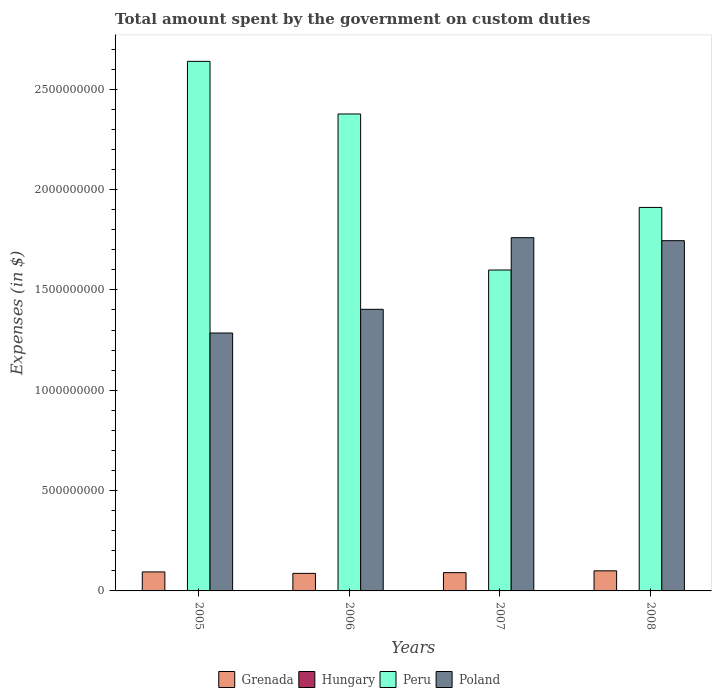How many different coloured bars are there?
Your response must be concise. 3. Are the number of bars per tick equal to the number of legend labels?
Your answer should be very brief. No. How many bars are there on the 2nd tick from the right?
Ensure brevity in your answer.  3. What is the label of the 3rd group of bars from the left?
Your response must be concise. 2007. What is the amount spent on custom duties by the government in Peru in 2006?
Give a very brief answer. 2.38e+09. Across all years, what is the maximum amount spent on custom duties by the government in Poland?
Make the answer very short. 1.76e+09. Across all years, what is the minimum amount spent on custom duties by the government in Hungary?
Offer a very short reply. 0. In which year was the amount spent on custom duties by the government in Poland maximum?
Your response must be concise. 2007. What is the difference between the amount spent on custom duties by the government in Peru in 2007 and that in 2008?
Your answer should be very brief. -3.12e+08. What is the difference between the amount spent on custom duties by the government in Poland in 2008 and the amount spent on custom duties by the government in Peru in 2006?
Offer a very short reply. -6.31e+08. What is the average amount spent on custom duties by the government in Peru per year?
Your answer should be compact. 2.13e+09. In the year 2005, what is the difference between the amount spent on custom duties by the government in Poland and amount spent on custom duties by the government in Grenada?
Your answer should be compact. 1.19e+09. In how many years, is the amount spent on custom duties by the government in Poland greater than 500000000 $?
Keep it short and to the point. 4. What is the ratio of the amount spent on custom duties by the government in Peru in 2005 to that in 2008?
Provide a succinct answer. 1.38. What is the difference between the highest and the second highest amount spent on custom duties by the government in Peru?
Offer a very short reply. 2.62e+08. What is the difference between the highest and the lowest amount spent on custom duties by the government in Peru?
Ensure brevity in your answer.  1.04e+09. In how many years, is the amount spent on custom duties by the government in Peru greater than the average amount spent on custom duties by the government in Peru taken over all years?
Your response must be concise. 2. Is it the case that in every year, the sum of the amount spent on custom duties by the government in Hungary and amount spent on custom duties by the government in Poland is greater than the sum of amount spent on custom duties by the government in Grenada and amount spent on custom duties by the government in Peru?
Keep it short and to the point. Yes. How many bars are there?
Make the answer very short. 12. Are all the bars in the graph horizontal?
Give a very brief answer. No. How many years are there in the graph?
Offer a very short reply. 4. What is the difference between two consecutive major ticks on the Y-axis?
Your answer should be very brief. 5.00e+08. Where does the legend appear in the graph?
Offer a very short reply. Bottom center. How are the legend labels stacked?
Your answer should be very brief. Horizontal. What is the title of the graph?
Offer a terse response. Total amount spent by the government on custom duties. What is the label or title of the X-axis?
Your answer should be very brief. Years. What is the label or title of the Y-axis?
Keep it short and to the point. Expenses (in $). What is the Expenses (in $) of Grenada in 2005?
Provide a short and direct response. 9.47e+07. What is the Expenses (in $) in Hungary in 2005?
Provide a short and direct response. 0. What is the Expenses (in $) of Peru in 2005?
Provide a succinct answer. 2.64e+09. What is the Expenses (in $) of Poland in 2005?
Provide a succinct answer. 1.28e+09. What is the Expenses (in $) of Grenada in 2006?
Ensure brevity in your answer.  8.74e+07. What is the Expenses (in $) in Peru in 2006?
Ensure brevity in your answer.  2.38e+09. What is the Expenses (in $) of Poland in 2006?
Provide a succinct answer. 1.40e+09. What is the Expenses (in $) in Grenada in 2007?
Make the answer very short. 9.11e+07. What is the Expenses (in $) in Peru in 2007?
Keep it short and to the point. 1.60e+09. What is the Expenses (in $) in Poland in 2007?
Your answer should be very brief. 1.76e+09. What is the Expenses (in $) in Grenada in 2008?
Offer a very short reply. 1.00e+08. What is the Expenses (in $) of Peru in 2008?
Your answer should be very brief. 1.91e+09. What is the Expenses (in $) of Poland in 2008?
Keep it short and to the point. 1.74e+09. Across all years, what is the maximum Expenses (in $) of Grenada?
Your answer should be compact. 1.00e+08. Across all years, what is the maximum Expenses (in $) of Peru?
Provide a short and direct response. 2.64e+09. Across all years, what is the maximum Expenses (in $) in Poland?
Your answer should be very brief. 1.76e+09. Across all years, what is the minimum Expenses (in $) of Grenada?
Provide a succinct answer. 8.74e+07. Across all years, what is the minimum Expenses (in $) of Peru?
Provide a succinct answer. 1.60e+09. Across all years, what is the minimum Expenses (in $) in Poland?
Provide a succinct answer. 1.28e+09. What is the total Expenses (in $) of Grenada in the graph?
Offer a terse response. 3.73e+08. What is the total Expenses (in $) in Peru in the graph?
Your answer should be compact. 8.52e+09. What is the total Expenses (in $) in Poland in the graph?
Your answer should be compact. 6.19e+09. What is the difference between the Expenses (in $) of Grenada in 2005 and that in 2006?
Your answer should be compact. 7.30e+06. What is the difference between the Expenses (in $) of Peru in 2005 and that in 2006?
Provide a succinct answer. 2.62e+08. What is the difference between the Expenses (in $) of Poland in 2005 and that in 2006?
Your answer should be very brief. -1.18e+08. What is the difference between the Expenses (in $) of Grenada in 2005 and that in 2007?
Give a very brief answer. 3.60e+06. What is the difference between the Expenses (in $) in Peru in 2005 and that in 2007?
Ensure brevity in your answer.  1.04e+09. What is the difference between the Expenses (in $) in Poland in 2005 and that in 2007?
Keep it short and to the point. -4.75e+08. What is the difference between the Expenses (in $) in Grenada in 2005 and that in 2008?
Give a very brief answer. -5.40e+06. What is the difference between the Expenses (in $) of Peru in 2005 and that in 2008?
Ensure brevity in your answer.  7.28e+08. What is the difference between the Expenses (in $) of Poland in 2005 and that in 2008?
Your answer should be compact. -4.60e+08. What is the difference between the Expenses (in $) in Grenada in 2006 and that in 2007?
Your response must be concise. -3.70e+06. What is the difference between the Expenses (in $) of Peru in 2006 and that in 2007?
Provide a succinct answer. 7.77e+08. What is the difference between the Expenses (in $) in Poland in 2006 and that in 2007?
Provide a succinct answer. -3.57e+08. What is the difference between the Expenses (in $) of Grenada in 2006 and that in 2008?
Your answer should be compact. -1.27e+07. What is the difference between the Expenses (in $) of Peru in 2006 and that in 2008?
Give a very brief answer. 4.66e+08. What is the difference between the Expenses (in $) in Poland in 2006 and that in 2008?
Provide a short and direct response. -3.42e+08. What is the difference between the Expenses (in $) in Grenada in 2007 and that in 2008?
Your answer should be compact. -9.00e+06. What is the difference between the Expenses (in $) in Peru in 2007 and that in 2008?
Provide a succinct answer. -3.12e+08. What is the difference between the Expenses (in $) in Poland in 2007 and that in 2008?
Give a very brief answer. 1.50e+07. What is the difference between the Expenses (in $) of Grenada in 2005 and the Expenses (in $) of Peru in 2006?
Keep it short and to the point. -2.28e+09. What is the difference between the Expenses (in $) of Grenada in 2005 and the Expenses (in $) of Poland in 2006?
Your response must be concise. -1.31e+09. What is the difference between the Expenses (in $) of Peru in 2005 and the Expenses (in $) of Poland in 2006?
Your answer should be compact. 1.24e+09. What is the difference between the Expenses (in $) in Grenada in 2005 and the Expenses (in $) in Peru in 2007?
Offer a terse response. -1.50e+09. What is the difference between the Expenses (in $) of Grenada in 2005 and the Expenses (in $) of Poland in 2007?
Your answer should be compact. -1.67e+09. What is the difference between the Expenses (in $) in Peru in 2005 and the Expenses (in $) in Poland in 2007?
Offer a terse response. 8.78e+08. What is the difference between the Expenses (in $) of Grenada in 2005 and the Expenses (in $) of Peru in 2008?
Keep it short and to the point. -1.82e+09. What is the difference between the Expenses (in $) of Grenada in 2005 and the Expenses (in $) of Poland in 2008?
Give a very brief answer. -1.65e+09. What is the difference between the Expenses (in $) in Peru in 2005 and the Expenses (in $) in Poland in 2008?
Make the answer very short. 8.94e+08. What is the difference between the Expenses (in $) of Grenada in 2006 and the Expenses (in $) of Peru in 2007?
Your response must be concise. -1.51e+09. What is the difference between the Expenses (in $) in Grenada in 2006 and the Expenses (in $) in Poland in 2007?
Ensure brevity in your answer.  -1.67e+09. What is the difference between the Expenses (in $) in Peru in 2006 and the Expenses (in $) in Poland in 2007?
Your answer should be very brief. 6.16e+08. What is the difference between the Expenses (in $) in Grenada in 2006 and the Expenses (in $) in Peru in 2008?
Offer a terse response. -1.82e+09. What is the difference between the Expenses (in $) in Grenada in 2006 and the Expenses (in $) in Poland in 2008?
Your answer should be very brief. -1.66e+09. What is the difference between the Expenses (in $) in Peru in 2006 and the Expenses (in $) in Poland in 2008?
Make the answer very short. 6.31e+08. What is the difference between the Expenses (in $) in Grenada in 2007 and the Expenses (in $) in Peru in 2008?
Give a very brief answer. -1.82e+09. What is the difference between the Expenses (in $) of Grenada in 2007 and the Expenses (in $) of Poland in 2008?
Ensure brevity in your answer.  -1.65e+09. What is the difference between the Expenses (in $) of Peru in 2007 and the Expenses (in $) of Poland in 2008?
Make the answer very short. -1.46e+08. What is the average Expenses (in $) in Grenada per year?
Your response must be concise. 9.33e+07. What is the average Expenses (in $) in Peru per year?
Provide a succinct answer. 2.13e+09. What is the average Expenses (in $) of Poland per year?
Keep it short and to the point. 1.55e+09. In the year 2005, what is the difference between the Expenses (in $) of Grenada and Expenses (in $) of Peru?
Your response must be concise. -2.54e+09. In the year 2005, what is the difference between the Expenses (in $) in Grenada and Expenses (in $) in Poland?
Provide a succinct answer. -1.19e+09. In the year 2005, what is the difference between the Expenses (in $) of Peru and Expenses (in $) of Poland?
Provide a short and direct response. 1.35e+09. In the year 2006, what is the difference between the Expenses (in $) in Grenada and Expenses (in $) in Peru?
Give a very brief answer. -2.29e+09. In the year 2006, what is the difference between the Expenses (in $) in Grenada and Expenses (in $) in Poland?
Provide a succinct answer. -1.32e+09. In the year 2006, what is the difference between the Expenses (in $) in Peru and Expenses (in $) in Poland?
Make the answer very short. 9.73e+08. In the year 2007, what is the difference between the Expenses (in $) of Grenada and Expenses (in $) of Peru?
Your answer should be very brief. -1.51e+09. In the year 2007, what is the difference between the Expenses (in $) in Grenada and Expenses (in $) in Poland?
Offer a very short reply. -1.67e+09. In the year 2007, what is the difference between the Expenses (in $) of Peru and Expenses (in $) of Poland?
Provide a succinct answer. -1.61e+08. In the year 2008, what is the difference between the Expenses (in $) in Grenada and Expenses (in $) in Peru?
Make the answer very short. -1.81e+09. In the year 2008, what is the difference between the Expenses (in $) in Grenada and Expenses (in $) in Poland?
Your response must be concise. -1.64e+09. In the year 2008, what is the difference between the Expenses (in $) of Peru and Expenses (in $) of Poland?
Keep it short and to the point. 1.66e+08. What is the ratio of the Expenses (in $) in Grenada in 2005 to that in 2006?
Make the answer very short. 1.08. What is the ratio of the Expenses (in $) in Peru in 2005 to that in 2006?
Your answer should be very brief. 1.11. What is the ratio of the Expenses (in $) of Poland in 2005 to that in 2006?
Keep it short and to the point. 0.92. What is the ratio of the Expenses (in $) of Grenada in 2005 to that in 2007?
Provide a short and direct response. 1.04. What is the ratio of the Expenses (in $) of Peru in 2005 to that in 2007?
Your answer should be very brief. 1.65. What is the ratio of the Expenses (in $) in Poland in 2005 to that in 2007?
Provide a succinct answer. 0.73. What is the ratio of the Expenses (in $) of Grenada in 2005 to that in 2008?
Provide a short and direct response. 0.95. What is the ratio of the Expenses (in $) of Peru in 2005 to that in 2008?
Offer a terse response. 1.38. What is the ratio of the Expenses (in $) in Poland in 2005 to that in 2008?
Your response must be concise. 0.74. What is the ratio of the Expenses (in $) in Grenada in 2006 to that in 2007?
Provide a short and direct response. 0.96. What is the ratio of the Expenses (in $) of Peru in 2006 to that in 2007?
Keep it short and to the point. 1.49. What is the ratio of the Expenses (in $) of Poland in 2006 to that in 2007?
Ensure brevity in your answer.  0.8. What is the ratio of the Expenses (in $) in Grenada in 2006 to that in 2008?
Offer a terse response. 0.87. What is the ratio of the Expenses (in $) of Peru in 2006 to that in 2008?
Your answer should be compact. 1.24. What is the ratio of the Expenses (in $) of Poland in 2006 to that in 2008?
Ensure brevity in your answer.  0.8. What is the ratio of the Expenses (in $) in Grenada in 2007 to that in 2008?
Provide a short and direct response. 0.91. What is the ratio of the Expenses (in $) of Peru in 2007 to that in 2008?
Ensure brevity in your answer.  0.84. What is the ratio of the Expenses (in $) in Poland in 2007 to that in 2008?
Keep it short and to the point. 1.01. What is the difference between the highest and the second highest Expenses (in $) of Grenada?
Keep it short and to the point. 5.40e+06. What is the difference between the highest and the second highest Expenses (in $) in Peru?
Provide a short and direct response. 2.62e+08. What is the difference between the highest and the second highest Expenses (in $) of Poland?
Your answer should be very brief. 1.50e+07. What is the difference between the highest and the lowest Expenses (in $) in Grenada?
Your answer should be very brief. 1.27e+07. What is the difference between the highest and the lowest Expenses (in $) in Peru?
Your answer should be very brief. 1.04e+09. What is the difference between the highest and the lowest Expenses (in $) of Poland?
Keep it short and to the point. 4.75e+08. 